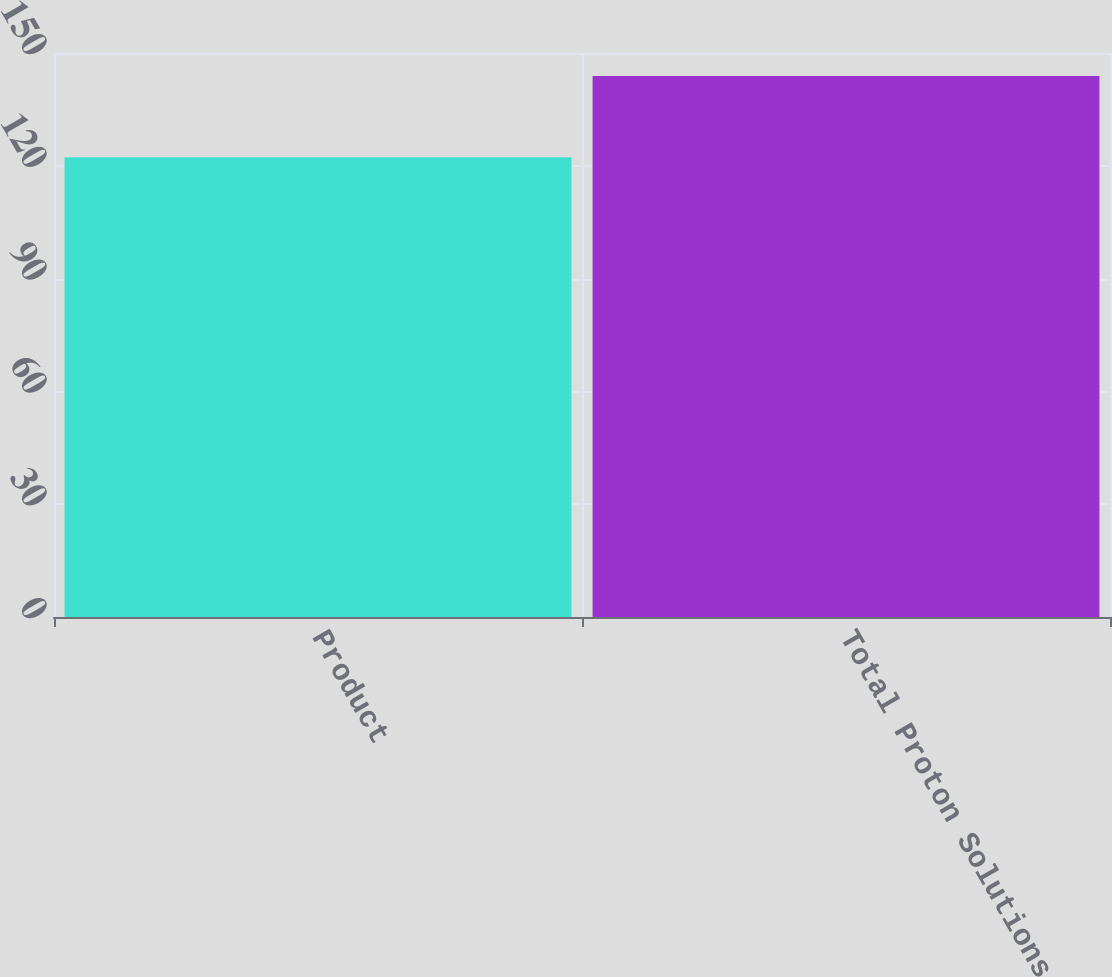<chart> <loc_0><loc_0><loc_500><loc_500><bar_chart><fcel>Product<fcel>Total Proton Solutions<nl><fcel>122.3<fcel>143.9<nl></chart> 